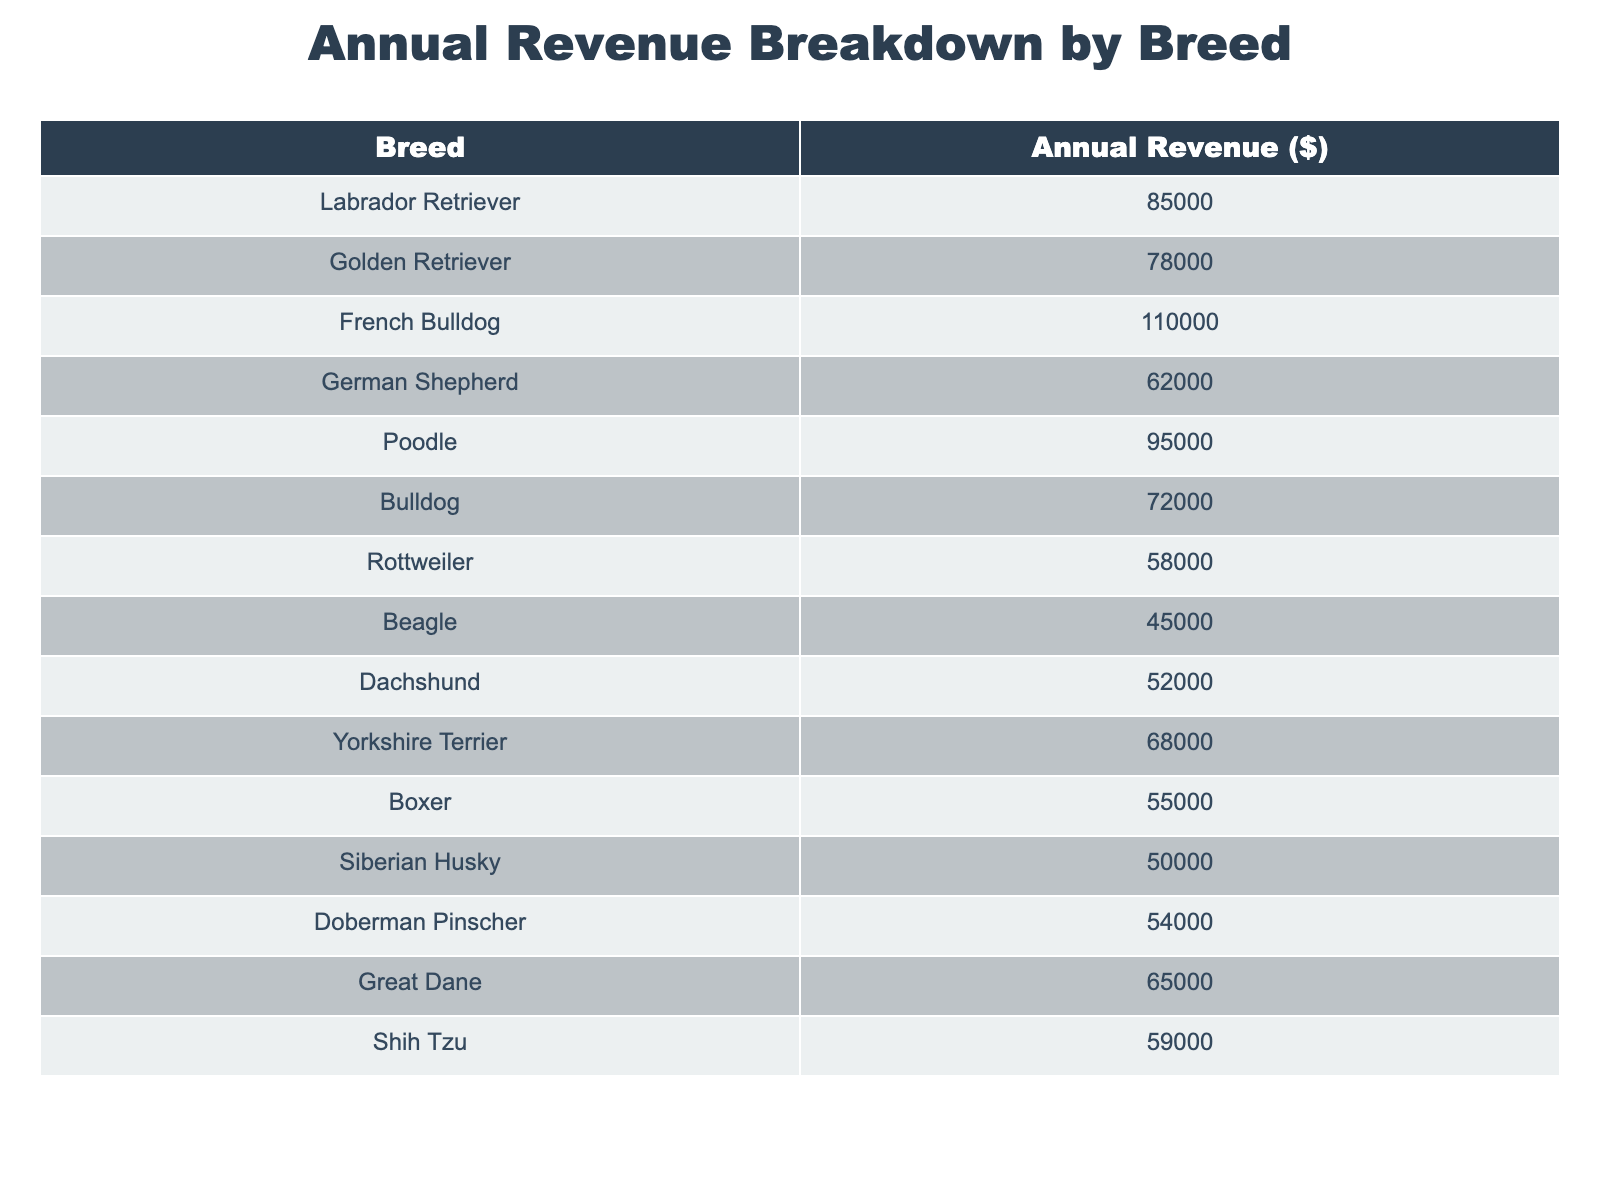What is the highest annual revenue from a single breed? The table shows that the French Bulldog has the highest revenue at $110,000, which is found by comparing all the values listed for each breed.
Answer: $110,000 How much revenue does the German Shepherd generate? From the table, the revenue for the German Shepherd is directly listed as $62,000.
Answer: $62,000 Which breeds generate more than $70,000 annually? By examining the table, the breeds that generate more than $70,000 are Labrador Retriever ($85,000), Golden Retriever ($78,000), French Bulldog ($110,000), and Poodle ($95,000).
Answer: Labrador Retriever, Golden Retriever, French Bulldog, Poodle What is the total revenue from all the breeds listed? To find the total revenue, add all the annual revenues together: $85,000 + $78,000 + $110,000 + $62,000 + $95,000 + $72,000 + $58,000 + $45,000 + $52,000 + $68,000 + $55,000 + $50,000 + $54,000 + $65,000 + $59,000 = $1,060,000.
Answer: $1,060,000 What is the average annual revenue per breed? There are 15 breeds in total, so to find the average, first calculate the total revenue which is $1,060,000, and then divide this by the number of breeds: $1,060,000 / 15 = $70,666.67 approximately.
Answer: $70,666.67 Is the overall revenue of Poodles higher than that of Rottweilers? The revenue for Poodles is $95,000 and for Rottweilers it is $58,000. Since $95,000 is greater than $58,000, this statement is true.
Answer: Yes Which breed has the lowest annual revenue? By reviewing the table, the Beagle has the lowest annual revenue listed at $45,000.
Answer: Beagle What is the difference in revenue between the highest and lowest earning breeds? The highest revenue is from the French Bulldog at $110,000 and the lowest from the Beagle at $45,000. The difference is calculated as $110,000 - $45,000 = $65,000.
Answer: $65,000 How many breeds earn between $50,000 and $70,000? By examining the table, the breeds that earn between $50,000 and $70,000 are Bulldog ($72,000), Beagle ($45,000), Yorkshire Terrier ($68,000), Boxer ($55,000), and Doberman Pinscher ($54,000), totaling to 6 breeds.
Answer: 6 breeds What is the total revenue from the breeds that generate less than $60,000? The breeds with less than $60,000 are Rottweiler ($58,000), Beagle ($45,000), Dachshund ($52,000), Siberian Husky ($50,000), and Doberman Pinscher ($54,000). Adding these revenues gives $58,000 + $45,000 + $52,000 + $50,000 + $54,000 = $259,000.
Answer: $259,000 If we combine the revenues of the Golden Retriever and Poodle, what is the total? The revenue for the Golden Retriever is $78,000 and for Poodle is $95,000. Adding these two gives: $78,000 + $95,000 = $173,000.
Answer: $173,000 